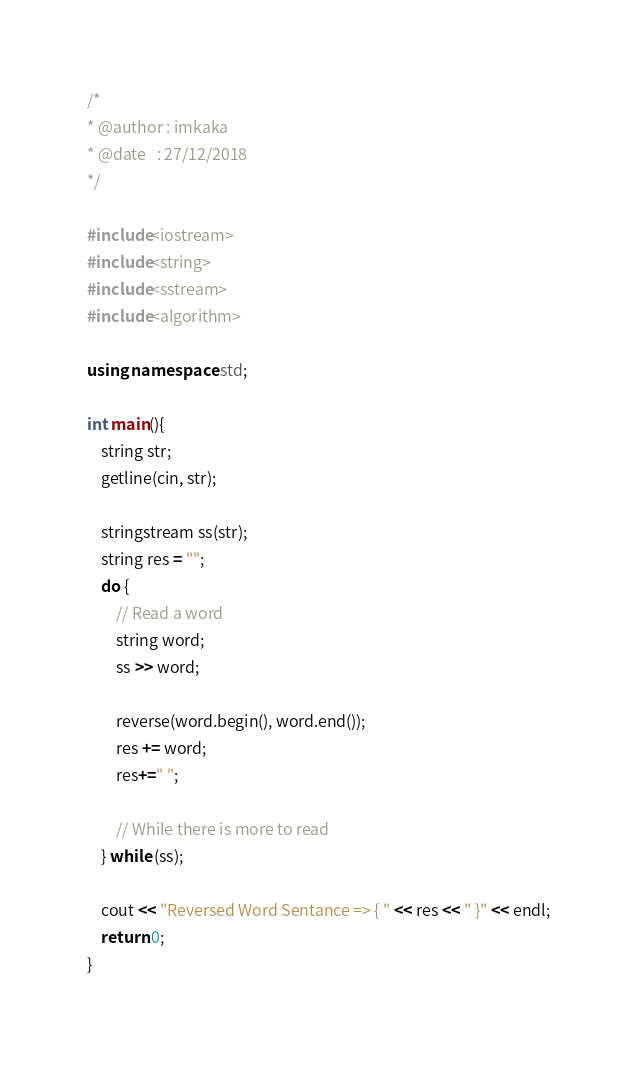Convert code to text. <code><loc_0><loc_0><loc_500><loc_500><_C++_>/*
* @author : imkaka
* @date   : 27/12/2018
*/

#include<iostream>
#include<string>
#include<sstream>
#include<algorithm>

using namespace std;

int main(){
    string str;
    getline(cin, str);

    stringstream ss(str);
    string res = "";
    do {
        // Read a word
        string word;
        ss >> word;

        reverse(word.begin(), word.end());
        res += word;
        res+=" ";

        // While there is more to read
    } while (ss);

    cout << "Reversed Word Sentance => { " << res << " }" << endl;
    return 0;
}
</code> 